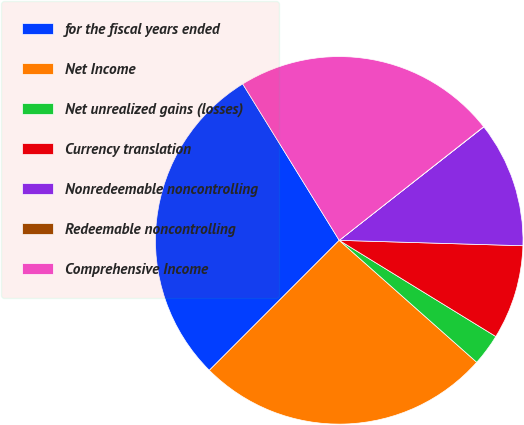Convert chart to OTSL. <chart><loc_0><loc_0><loc_500><loc_500><pie_chart><fcel>for the fiscal years ended<fcel>Net Income<fcel>Net unrealized gains (losses)<fcel>Currency translation<fcel>Nonredeemable noncontrolling<fcel>Redeemable noncontrolling<fcel>Comprehensive Income<nl><fcel>28.71%<fcel>25.95%<fcel>2.78%<fcel>8.3%<fcel>11.06%<fcel>0.02%<fcel>23.19%<nl></chart> 